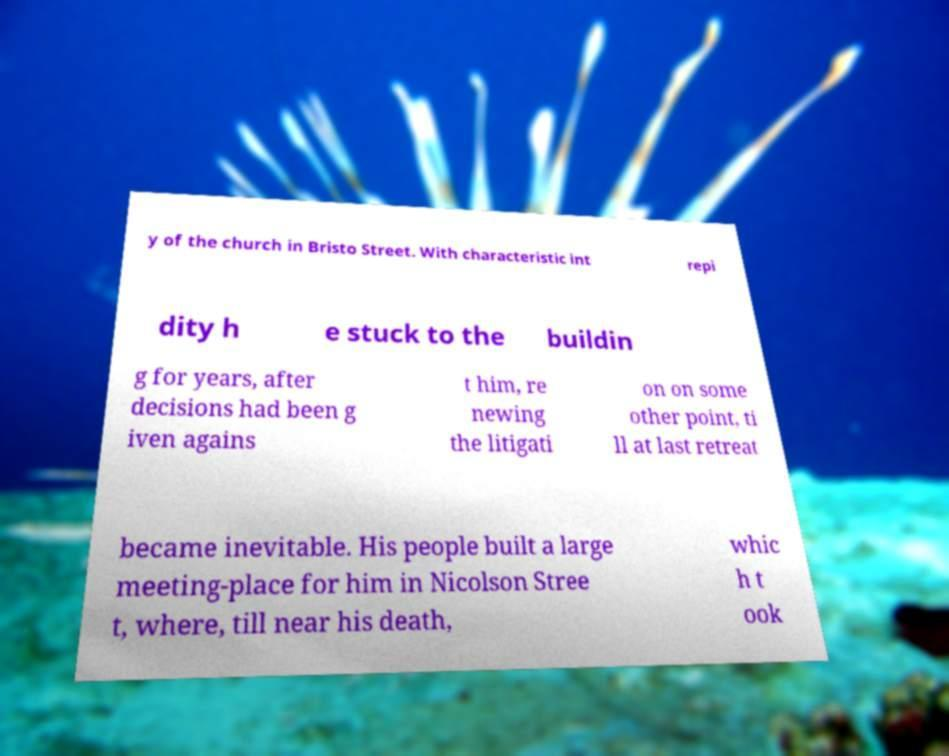Can you read and provide the text displayed in the image?This photo seems to have some interesting text. Can you extract and type it out for me? y of the church in Bristo Street. With characteristic int repi dity h e stuck to the buildin g for years, after decisions had been g iven agains t him, re newing the litigati on on some other point, ti ll at last retreat became inevitable. His people built a large meeting-place for him in Nicolson Stree t, where, till near his death, whic h t ook 